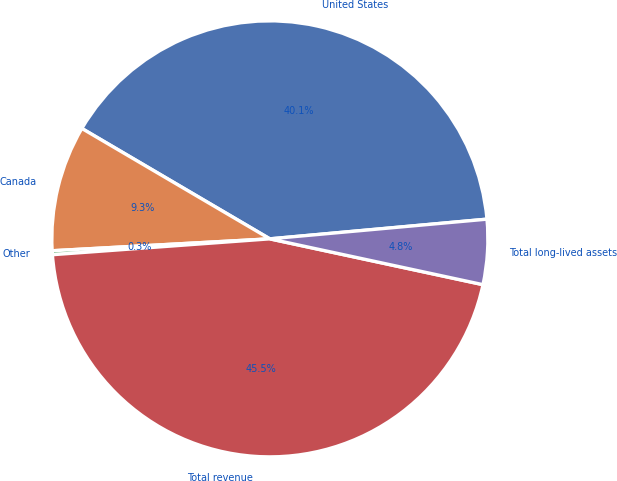Convert chart. <chart><loc_0><loc_0><loc_500><loc_500><pie_chart><fcel>United States<fcel>Canada<fcel>Other<fcel>Total revenue<fcel>Total long-lived assets<nl><fcel>40.11%<fcel>9.32%<fcel>0.29%<fcel>45.47%<fcel>4.81%<nl></chart> 